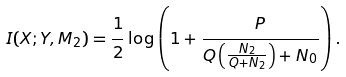Convert formula to latex. <formula><loc_0><loc_0><loc_500><loc_500>I ( X ; Y , M _ { 2 } ) = \frac { 1 } { 2 } \log \left ( 1 + \frac { P } { Q \left ( \frac { N _ { 2 } } { Q + N _ { 2 } } \right ) + N _ { 0 } } \right ) .</formula> 